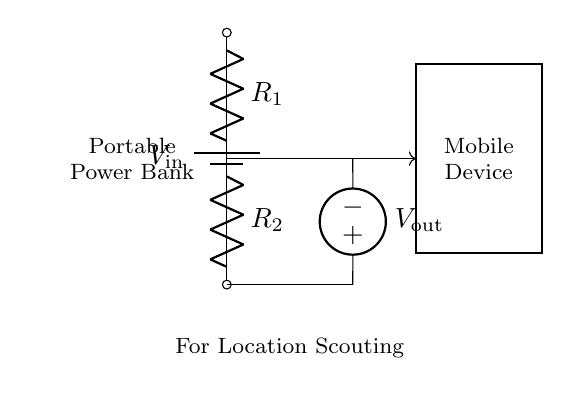What is the type of power source used in this circuit? The circuit diagram shows a battery as the power source, indicated by the symbol labeled V_input.
Answer: Battery What components are part of the voltage divider? The voltage divider consists of two resistors labeled R1 and R2 in series, which are connected to the voltage source.
Answer: R1 and R2 What is the purpose of the voltage divider in this circuit? The voltage divider reduces the input voltage V_input to a lower output voltage V_output, suitable for charging a mobile device.
Answer: Reduce voltage What is the output voltage labeled in this circuit? The output voltage is labeled as V_output, which is taken from the voltage divider and supplied to the mobile device.
Answer: V_output How many resistors are present in the voltage divider? There are two resistors listed in the circuit, which are R1 and R2, essential parts of the voltage divider configuration.
Answer: Two What do you infer about the connection of R1 and R2? Resistors R1 and R2 are connected in series, meaning the same current flows through both, while their voltage drops contribute to the overall voltage division.
Answer: Series What would happen if R1 is much larger than R2? If R1 is significantly larger than R2, the output voltage V_output would be closer to zero, as the higher resistance would dominate the voltage drop across the resistors.
Answer: V_output approaches zero 